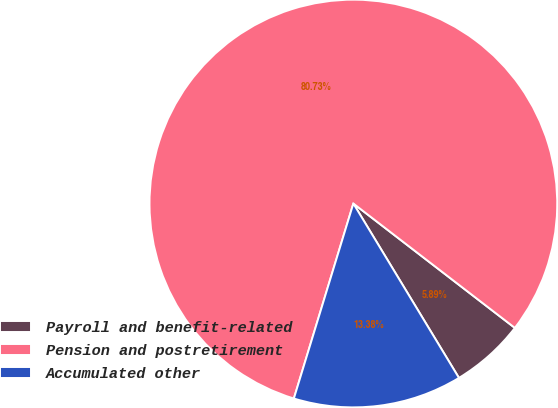Convert chart. <chart><loc_0><loc_0><loc_500><loc_500><pie_chart><fcel>Payroll and benefit-related<fcel>Pension and postretirement<fcel>Accumulated other<nl><fcel>5.89%<fcel>80.73%<fcel>13.38%<nl></chart> 